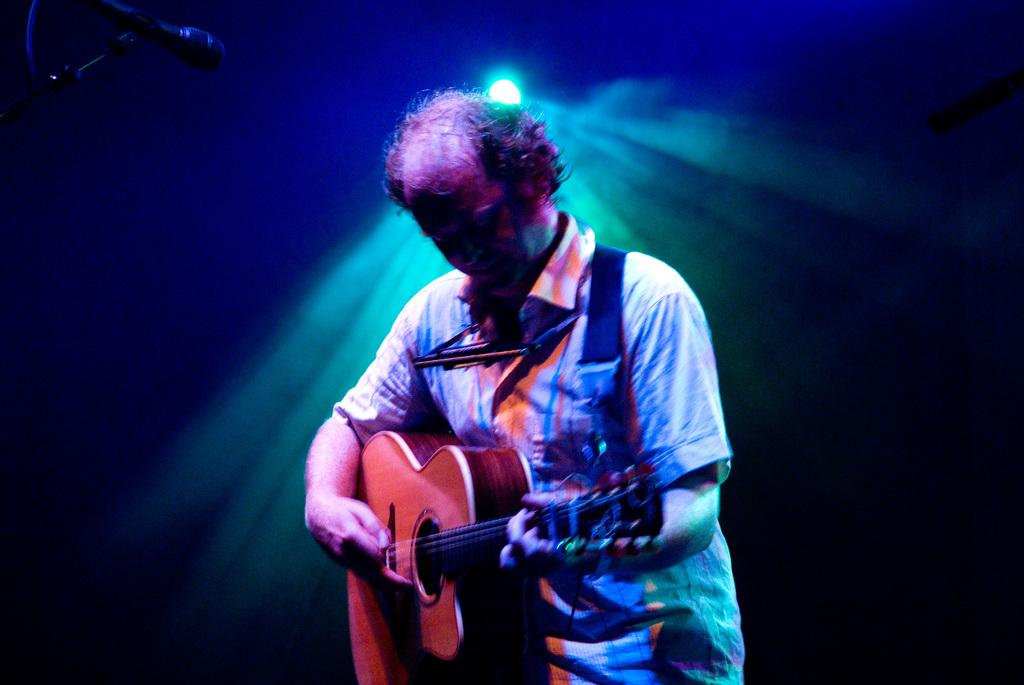Who is the main subject in the image? There is a man in the image. What is the man doing in the image? The man is playing a guitar. What object is present in the image that is commonly used for amplifying sound? There is a microphone in the image. What type of plot is visible in the background of the image? There is no plot visible in the image; it features a man playing a guitar and a microphone. Can you tell me how many ice cubes are in the man's drink in the image? There is no drink or ice cubes present in the image. 